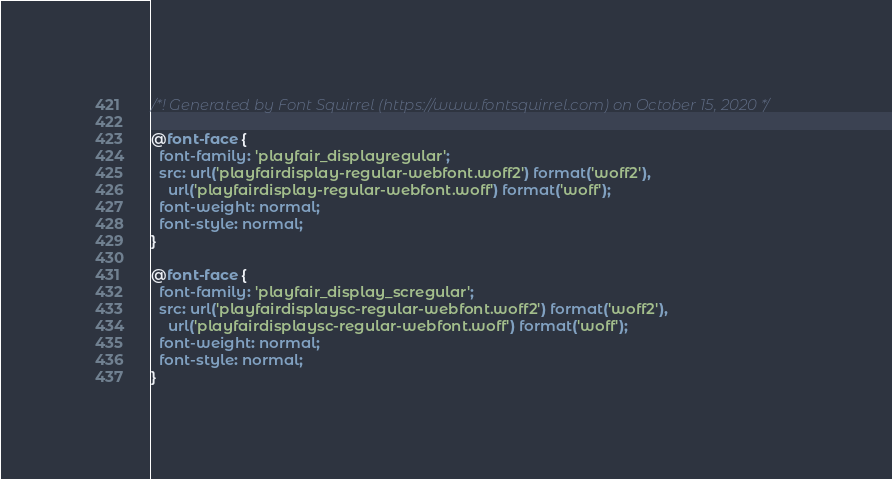Convert code to text. <code><loc_0><loc_0><loc_500><loc_500><_CSS_>/*! Generated by Font Squirrel (https://www.fontsquirrel.com) on October 15, 2020 */

@font-face {
  font-family: 'playfair_displayregular';
  src: url('playfairdisplay-regular-webfont.woff2') format('woff2'),
    url('playfairdisplay-regular-webfont.woff') format('woff');
  font-weight: normal;
  font-style: normal;
}

@font-face {
  font-family: 'playfair_display_scregular';
  src: url('playfairdisplaysc-regular-webfont.woff2') format('woff2'),
    url('playfairdisplaysc-regular-webfont.woff') format('woff');
  font-weight: normal;
  font-style: normal;
}
</code> 